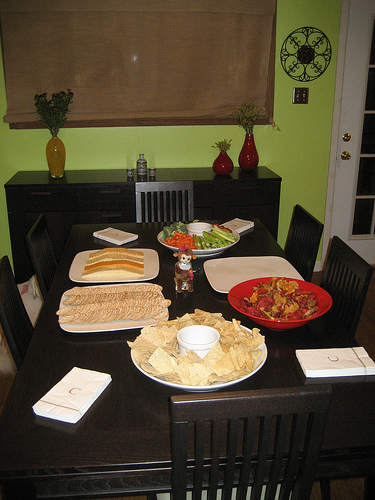<image>
Is there a food on the plate? No. The food is not positioned on the plate. They may be near each other, but the food is not supported by or resting on top of the plate. 